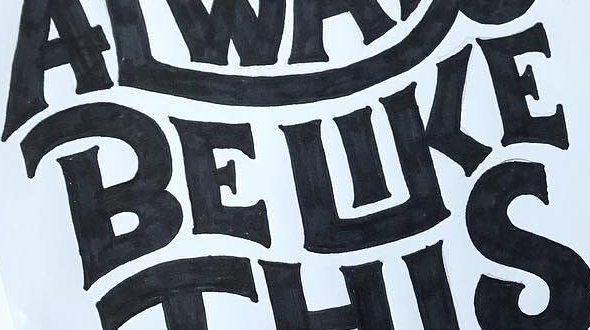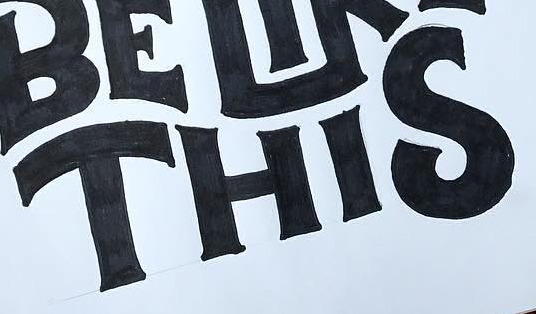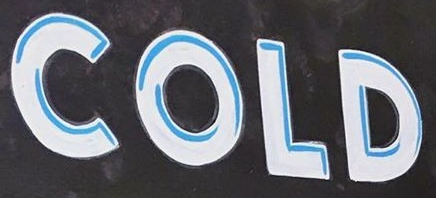Read the text content from these images in order, separated by a semicolon. BELIKE; THIS; COLD 